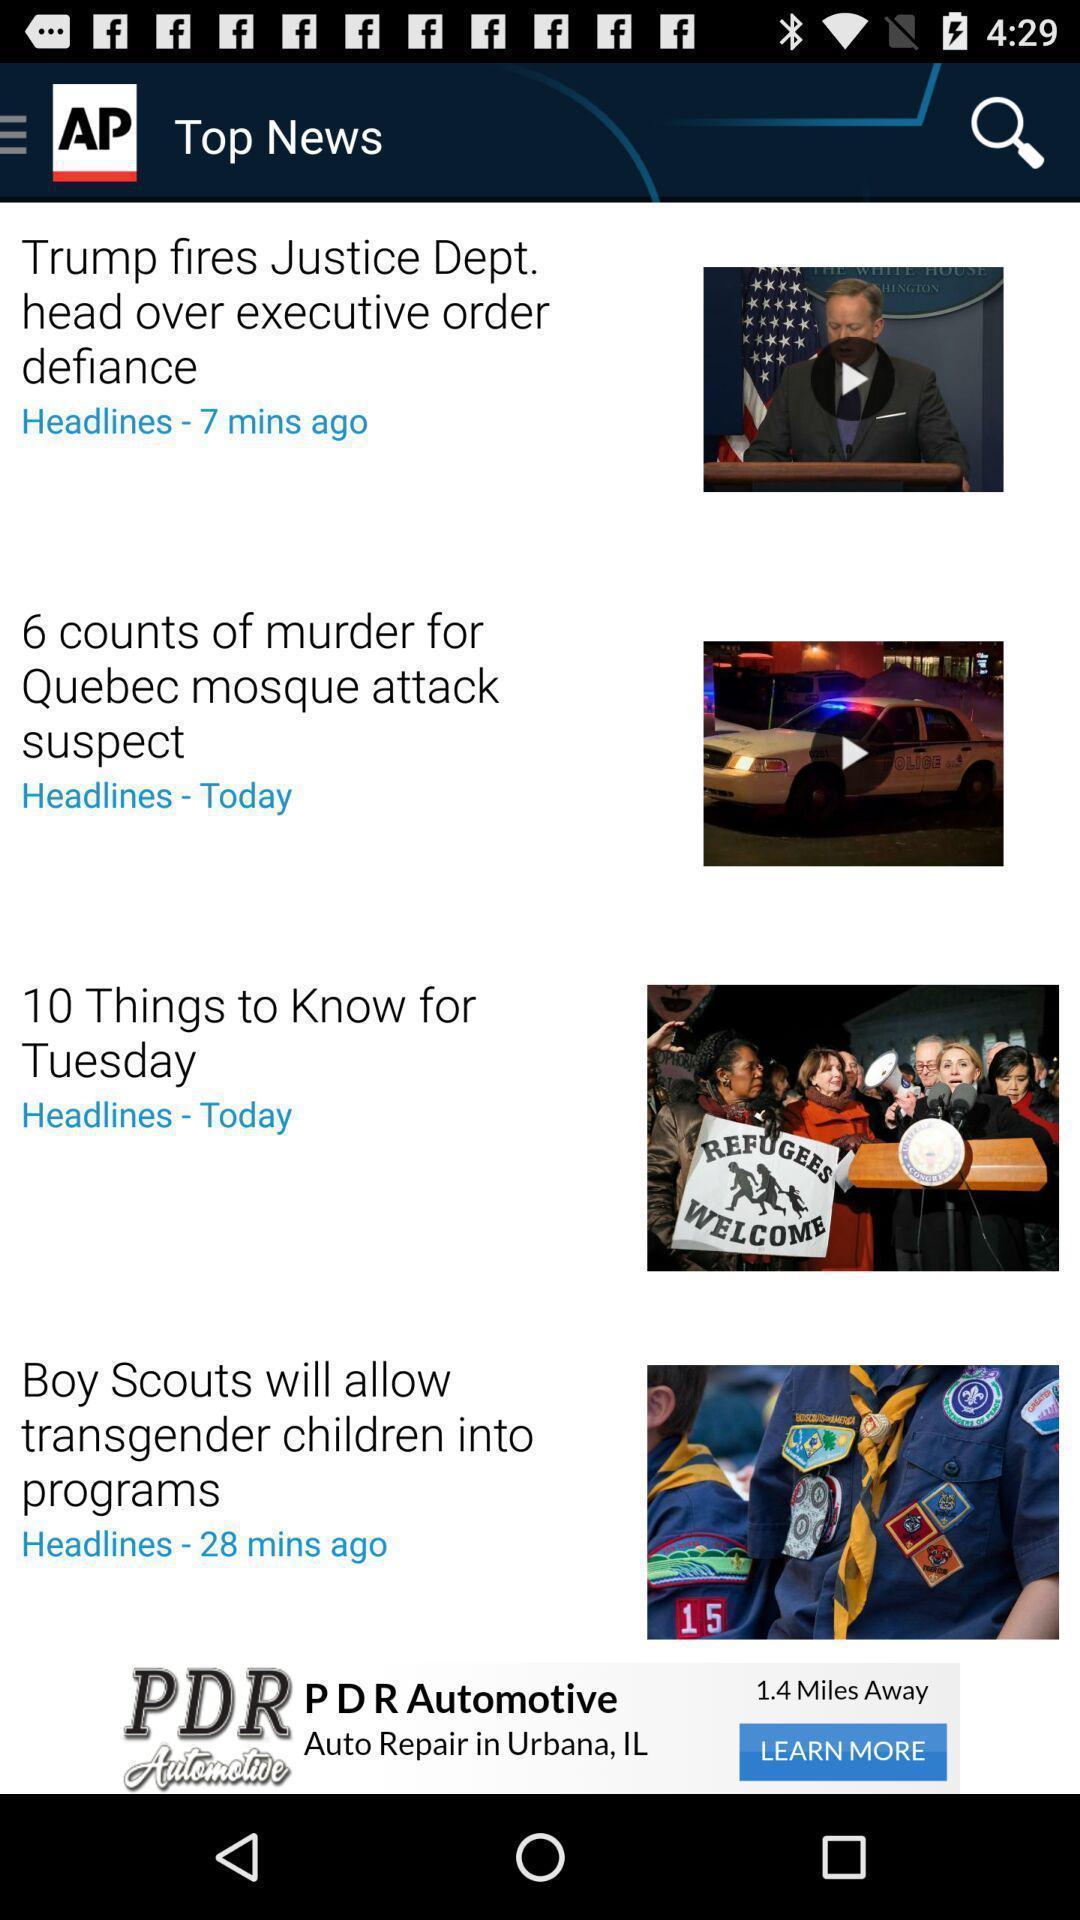Give me a summary of this screen capture. Screen page of a top news in a news app. 